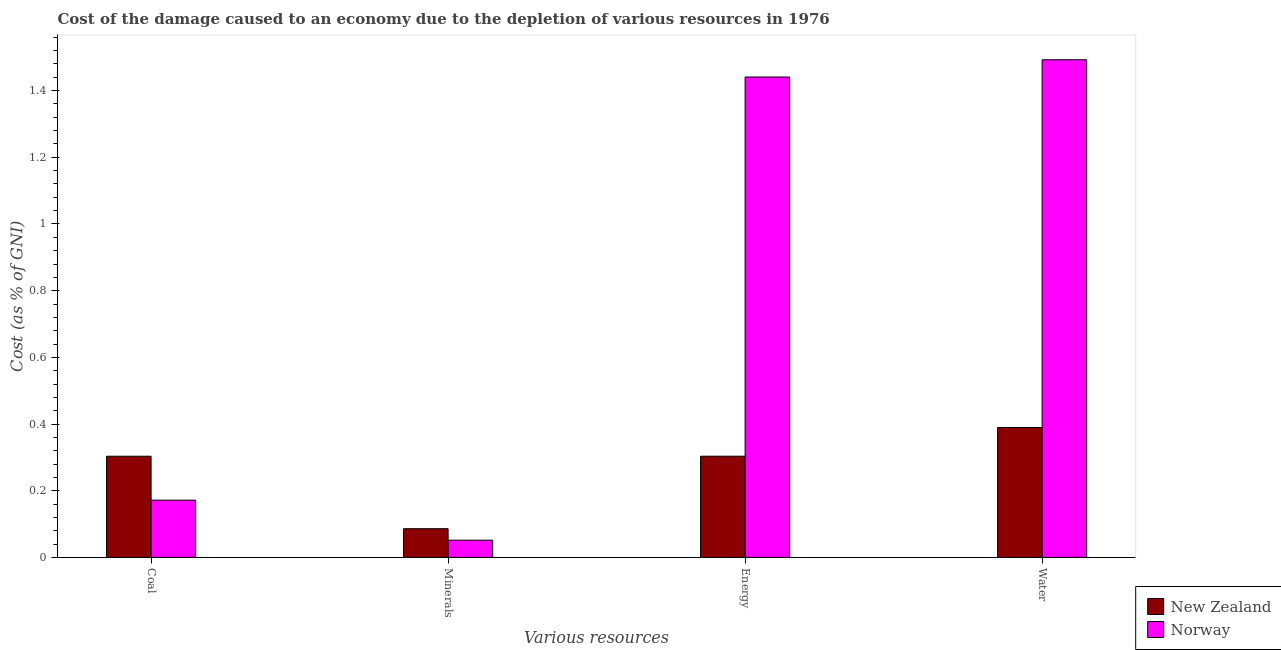How many different coloured bars are there?
Make the answer very short. 2. Are the number of bars per tick equal to the number of legend labels?
Provide a succinct answer. Yes. How many bars are there on the 2nd tick from the left?
Provide a succinct answer. 2. What is the label of the 1st group of bars from the left?
Offer a terse response. Coal. What is the cost of damage due to depletion of water in New Zealand?
Your answer should be very brief. 0.39. Across all countries, what is the maximum cost of damage due to depletion of minerals?
Make the answer very short. 0.09. Across all countries, what is the minimum cost of damage due to depletion of coal?
Give a very brief answer. 0.17. In which country was the cost of damage due to depletion of energy minimum?
Offer a terse response. New Zealand. What is the total cost of damage due to depletion of minerals in the graph?
Offer a terse response. 0.14. What is the difference between the cost of damage due to depletion of water in New Zealand and that in Norway?
Your response must be concise. -1.1. What is the difference between the cost of damage due to depletion of minerals in New Zealand and the cost of damage due to depletion of energy in Norway?
Provide a succinct answer. -1.35. What is the average cost of damage due to depletion of water per country?
Ensure brevity in your answer.  0.94. What is the difference between the cost of damage due to depletion of water and cost of damage due to depletion of minerals in Norway?
Keep it short and to the point. 1.44. In how many countries, is the cost of damage due to depletion of minerals greater than 1.2000000000000002 %?
Your answer should be compact. 0. What is the ratio of the cost of damage due to depletion of energy in New Zealand to that in Norway?
Keep it short and to the point. 0.21. Is the cost of damage due to depletion of water in New Zealand less than that in Norway?
Your response must be concise. Yes. What is the difference between the highest and the second highest cost of damage due to depletion of water?
Your answer should be very brief. 1.1. What is the difference between the highest and the lowest cost of damage due to depletion of minerals?
Your answer should be compact. 0.03. Is the sum of the cost of damage due to depletion of minerals in Norway and New Zealand greater than the maximum cost of damage due to depletion of coal across all countries?
Your answer should be very brief. No. What does the 1st bar from the left in Energy represents?
Keep it short and to the point. New Zealand. What does the 2nd bar from the right in Coal represents?
Your answer should be very brief. New Zealand. Is it the case that in every country, the sum of the cost of damage due to depletion of coal and cost of damage due to depletion of minerals is greater than the cost of damage due to depletion of energy?
Provide a succinct answer. No. How many countries are there in the graph?
Offer a very short reply. 2. What is the difference between two consecutive major ticks on the Y-axis?
Ensure brevity in your answer.  0.2. Are the values on the major ticks of Y-axis written in scientific E-notation?
Ensure brevity in your answer.  No. Does the graph contain any zero values?
Provide a succinct answer. No. How are the legend labels stacked?
Your answer should be compact. Vertical. What is the title of the graph?
Offer a terse response. Cost of the damage caused to an economy due to the depletion of various resources in 1976 . What is the label or title of the X-axis?
Your response must be concise. Various resources. What is the label or title of the Y-axis?
Provide a succinct answer. Cost (as % of GNI). What is the Cost (as % of GNI) in New Zealand in Coal?
Offer a very short reply. 0.3. What is the Cost (as % of GNI) in Norway in Coal?
Provide a succinct answer. 0.17. What is the Cost (as % of GNI) of New Zealand in Minerals?
Your answer should be very brief. 0.09. What is the Cost (as % of GNI) of Norway in Minerals?
Offer a very short reply. 0.05. What is the Cost (as % of GNI) of New Zealand in Energy?
Offer a terse response. 0.3. What is the Cost (as % of GNI) of Norway in Energy?
Give a very brief answer. 1.44. What is the Cost (as % of GNI) in New Zealand in Water?
Make the answer very short. 0.39. What is the Cost (as % of GNI) of Norway in Water?
Give a very brief answer. 1.49. Across all Various resources, what is the maximum Cost (as % of GNI) of New Zealand?
Make the answer very short. 0.39. Across all Various resources, what is the maximum Cost (as % of GNI) in Norway?
Provide a short and direct response. 1.49. Across all Various resources, what is the minimum Cost (as % of GNI) in New Zealand?
Ensure brevity in your answer.  0.09. Across all Various resources, what is the minimum Cost (as % of GNI) of Norway?
Provide a short and direct response. 0.05. What is the total Cost (as % of GNI) of New Zealand in the graph?
Your response must be concise. 1.08. What is the total Cost (as % of GNI) in Norway in the graph?
Provide a succinct answer. 3.16. What is the difference between the Cost (as % of GNI) in New Zealand in Coal and that in Minerals?
Your response must be concise. 0.22. What is the difference between the Cost (as % of GNI) of Norway in Coal and that in Minerals?
Your answer should be very brief. 0.12. What is the difference between the Cost (as % of GNI) of Norway in Coal and that in Energy?
Keep it short and to the point. -1.27. What is the difference between the Cost (as % of GNI) in New Zealand in Coal and that in Water?
Offer a terse response. -0.09. What is the difference between the Cost (as % of GNI) of Norway in Coal and that in Water?
Provide a short and direct response. -1.32. What is the difference between the Cost (as % of GNI) in New Zealand in Minerals and that in Energy?
Ensure brevity in your answer.  -0.22. What is the difference between the Cost (as % of GNI) of Norway in Minerals and that in Energy?
Make the answer very short. -1.39. What is the difference between the Cost (as % of GNI) of New Zealand in Minerals and that in Water?
Give a very brief answer. -0.3. What is the difference between the Cost (as % of GNI) of Norway in Minerals and that in Water?
Keep it short and to the point. -1.44. What is the difference between the Cost (as % of GNI) in New Zealand in Energy and that in Water?
Make the answer very short. -0.09. What is the difference between the Cost (as % of GNI) of Norway in Energy and that in Water?
Offer a terse response. -0.05. What is the difference between the Cost (as % of GNI) in New Zealand in Coal and the Cost (as % of GNI) in Norway in Minerals?
Give a very brief answer. 0.25. What is the difference between the Cost (as % of GNI) of New Zealand in Coal and the Cost (as % of GNI) of Norway in Energy?
Ensure brevity in your answer.  -1.14. What is the difference between the Cost (as % of GNI) of New Zealand in Coal and the Cost (as % of GNI) of Norway in Water?
Your response must be concise. -1.19. What is the difference between the Cost (as % of GNI) in New Zealand in Minerals and the Cost (as % of GNI) in Norway in Energy?
Ensure brevity in your answer.  -1.35. What is the difference between the Cost (as % of GNI) of New Zealand in Minerals and the Cost (as % of GNI) of Norway in Water?
Ensure brevity in your answer.  -1.41. What is the difference between the Cost (as % of GNI) in New Zealand in Energy and the Cost (as % of GNI) in Norway in Water?
Your answer should be very brief. -1.19. What is the average Cost (as % of GNI) in New Zealand per Various resources?
Offer a very short reply. 0.27. What is the average Cost (as % of GNI) in Norway per Various resources?
Keep it short and to the point. 0.79. What is the difference between the Cost (as % of GNI) of New Zealand and Cost (as % of GNI) of Norway in Coal?
Ensure brevity in your answer.  0.13. What is the difference between the Cost (as % of GNI) in New Zealand and Cost (as % of GNI) in Norway in Minerals?
Make the answer very short. 0.03. What is the difference between the Cost (as % of GNI) in New Zealand and Cost (as % of GNI) in Norway in Energy?
Keep it short and to the point. -1.14. What is the difference between the Cost (as % of GNI) in New Zealand and Cost (as % of GNI) in Norway in Water?
Offer a very short reply. -1.1. What is the ratio of the Cost (as % of GNI) of New Zealand in Coal to that in Minerals?
Your answer should be compact. 3.52. What is the ratio of the Cost (as % of GNI) of Norway in Coal to that in Minerals?
Offer a very short reply. 3.32. What is the ratio of the Cost (as % of GNI) of Norway in Coal to that in Energy?
Your answer should be very brief. 0.12. What is the ratio of the Cost (as % of GNI) of New Zealand in Coal to that in Water?
Your answer should be compact. 0.78. What is the ratio of the Cost (as % of GNI) of Norway in Coal to that in Water?
Your response must be concise. 0.12. What is the ratio of the Cost (as % of GNI) of New Zealand in Minerals to that in Energy?
Your response must be concise. 0.28. What is the ratio of the Cost (as % of GNI) of Norway in Minerals to that in Energy?
Your answer should be very brief. 0.04. What is the ratio of the Cost (as % of GNI) in New Zealand in Minerals to that in Water?
Make the answer very short. 0.22. What is the ratio of the Cost (as % of GNI) of Norway in Minerals to that in Water?
Make the answer very short. 0.03. What is the ratio of the Cost (as % of GNI) of New Zealand in Energy to that in Water?
Your response must be concise. 0.78. What is the ratio of the Cost (as % of GNI) in Norway in Energy to that in Water?
Give a very brief answer. 0.97. What is the difference between the highest and the second highest Cost (as % of GNI) of New Zealand?
Your answer should be compact. 0.09. What is the difference between the highest and the second highest Cost (as % of GNI) in Norway?
Your answer should be very brief. 0.05. What is the difference between the highest and the lowest Cost (as % of GNI) of New Zealand?
Make the answer very short. 0.3. What is the difference between the highest and the lowest Cost (as % of GNI) in Norway?
Keep it short and to the point. 1.44. 